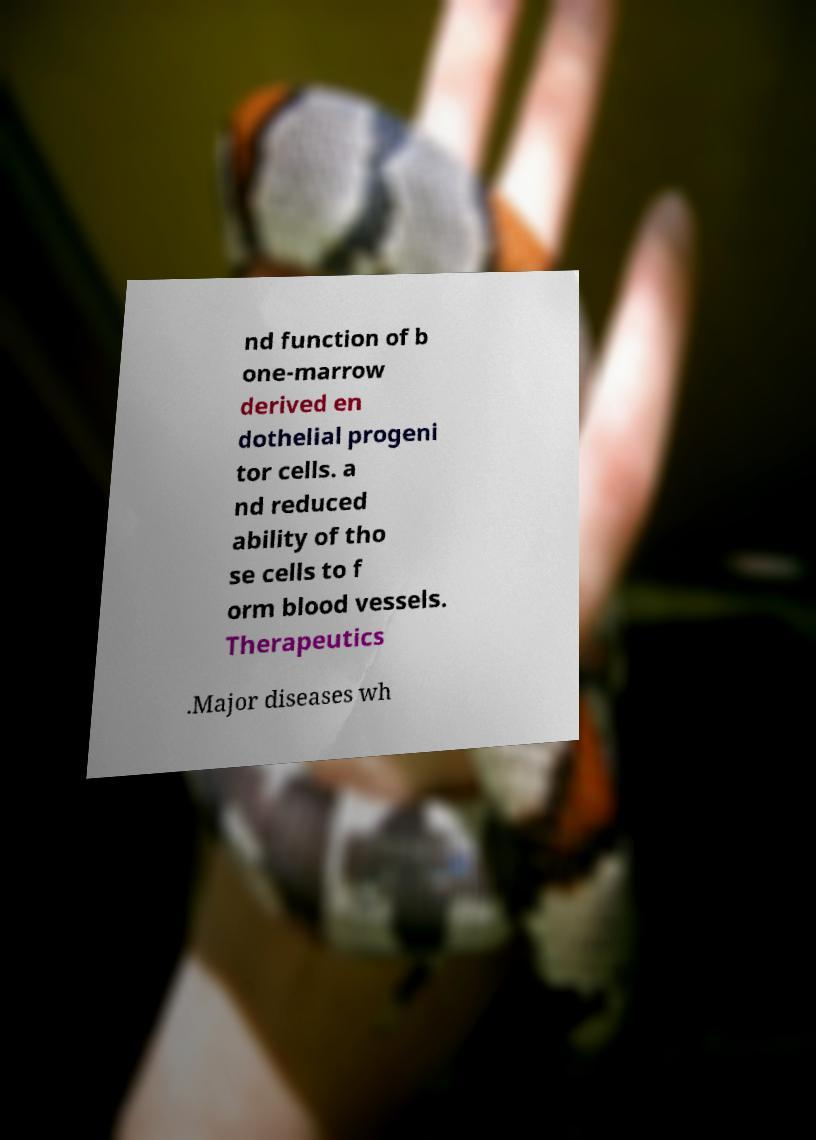I need the written content from this picture converted into text. Can you do that? nd function of b one-marrow derived en dothelial progeni tor cells. a nd reduced ability of tho se cells to f orm blood vessels. Therapeutics .Major diseases wh 